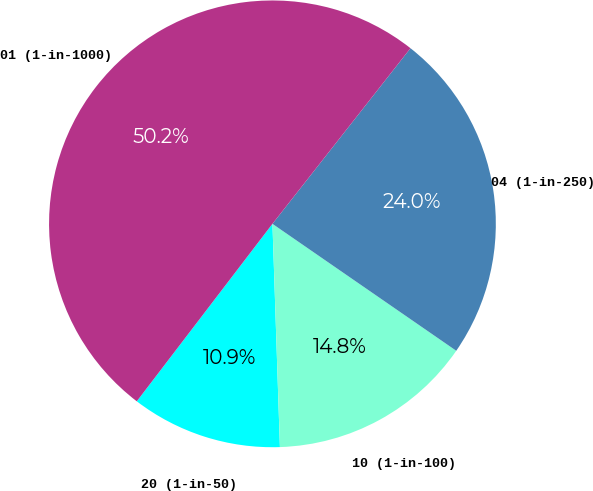Convert chart to OTSL. <chart><loc_0><loc_0><loc_500><loc_500><pie_chart><fcel>20 (1-in-50)<fcel>10 (1-in-100)<fcel>04 (1-in-250)<fcel>01 (1-in-1000)<nl><fcel>10.92%<fcel>14.85%<fcel>24.02%<fcel>50.22%<nl></chart> 